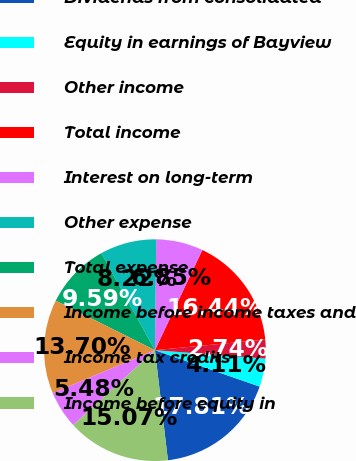Convert chart. <chart><loc_0><loc_0><loc_500><loc_500><pie_chart><fcel>Dividends from consolidated<fcel>Equity in earnings of Bayview<fcel>Other income<fcel>Total income<fcel>Interest on long-term<fcel>Other expense<fcel>Total expense<fcel>Income before income taxes and<fcel>Income tax credits<fcel>Income before equity in<nl><fcel>17.81%<fcel>4.11%<fcel>2.74%<fcel>16.44%<fcel>6.85%<fcel>8.22%<fcel>9.59%<fcel>13.7%<fcel>5.48%<fcel>15.07%<nl></chart> 